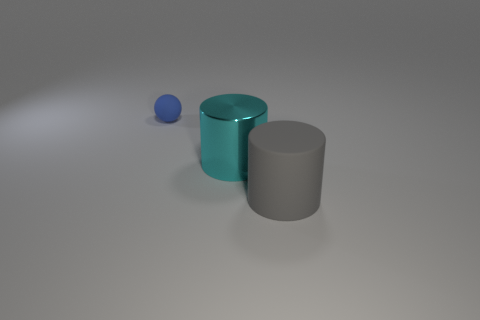Are there any other things that are made of the same material as the cyan object?
Keep it short and to the point. No. There is a blue thing that is to the left of the cylinder right of the cyan object; what is its material?
Your answer should be very brief. Rubber. There is another big object that is the same shape as the large shiny object; what is its material?
Your answer should be very brief. Rubber. What is the shape of the tiny thing that is the same material as the big gray cylinder?
Your response must be concise. Sphere. There is a cylinder that is left of the large gray matte object; what material is it?
Your answer should be very brief. Metal. There is a rubber object behind the rubber thing to the right of the tiny thing; what size is it?
Your answer should be very brief. Small. Are there more cyan metallic cylinders that are to the right of the tiny blue sphere than tiny brown matte blocks?
Provide a short and direct response. Yes. Does the matte thing that is in front of the blue matte ball have the same size as the big metallic cylinder?
Give a very brief answer. Yes. What color is the object that is left of the gray object and in front of the tiny matte object?
Provide a succinct answer. Cyan. There is another thing that is the same size as the gray thing; what shape is it?
Give a very brief answer. Cylinder. 